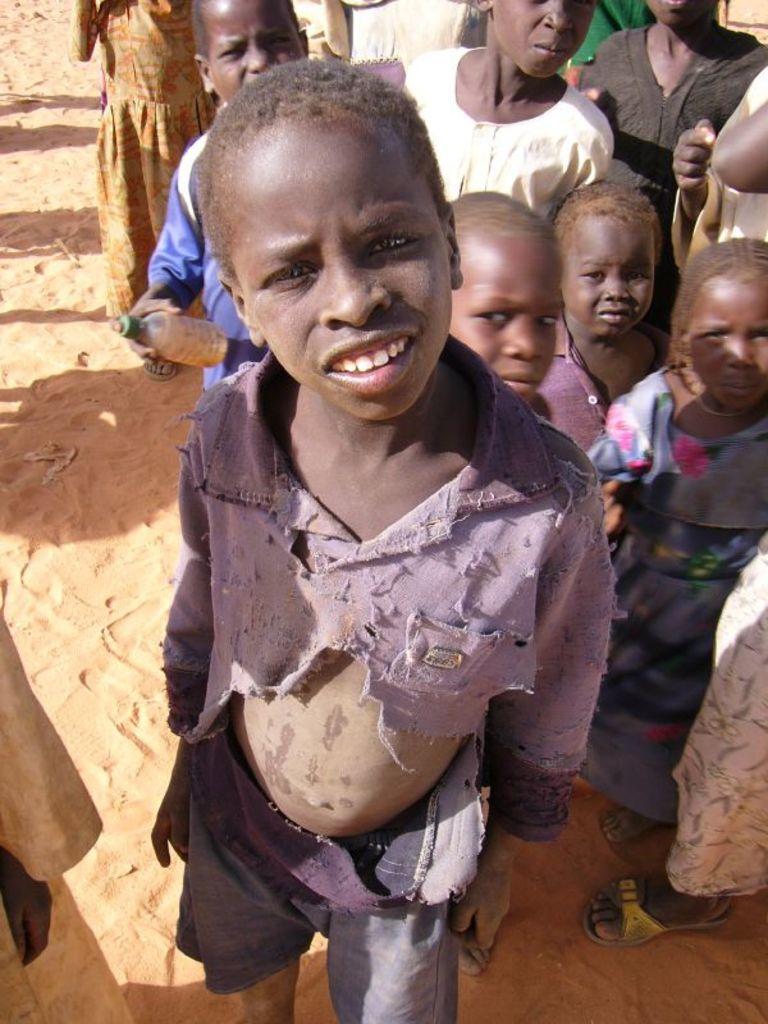Can you describe this image briefly? In this image there are people and sand. Among them one person is holding a bottle. 